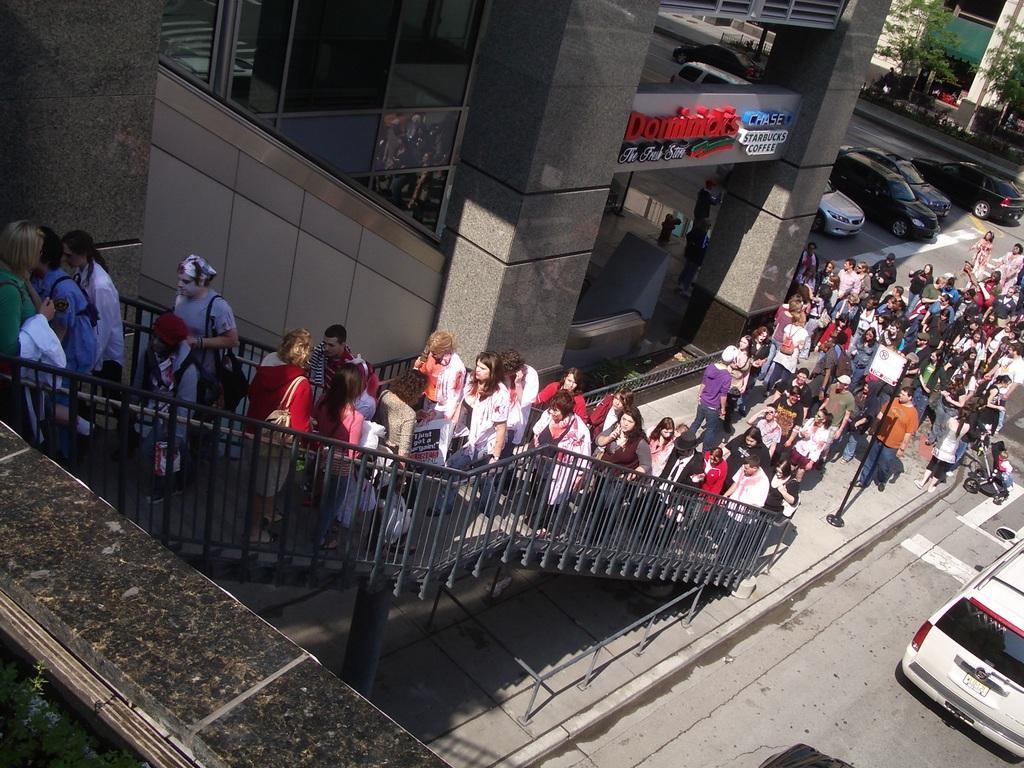Can you describe this image briefly? In this image I can see number of people are standing. I can also see stairs, few trees few, few buildings, a board, a pole and number of cars on these roads. I can also see something is written over here. 